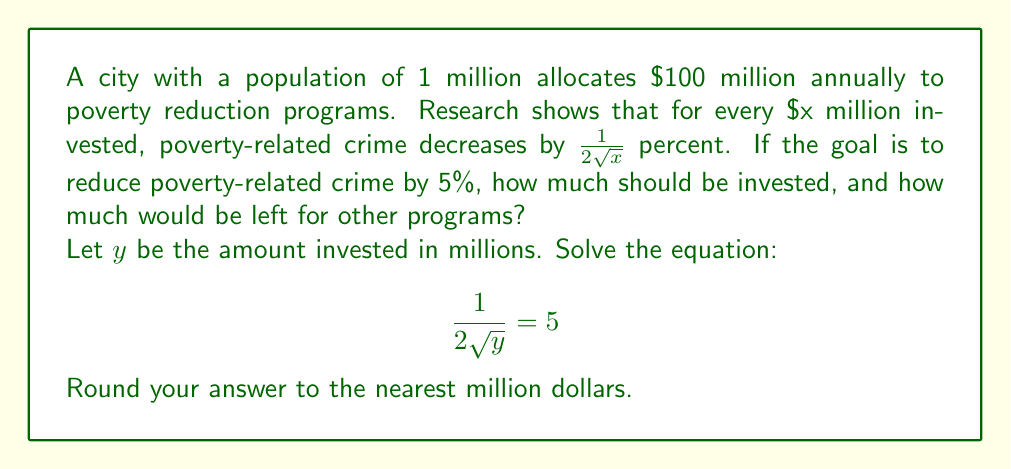Help me with this question. To solve this problem, we'll follow these steps:

1) Start with the equation:
   $$\frac{1}{2\sqrt{y}} = 5$$

2) Multiply both sides by $2\sqrt{y}$:
   $$1 = 10\sqrt{y}$$

3) Square both sides:
   $$1 = 100y$$

4) Divide both sides by 100:
   $$y = \frac{1}{100} = 0.01$$

5) Since $y$ is in millions of dollars, we multiply by 1,000,000:
   $$0.01 \times 1,000,000 = 10,000$$

6) Round to the nearest million:
   $10 million

7) Calculate the amount left for other programs:
   $100 million - $10 million = $90 million

Therefore, $10 million should be invested in poverty reduction programs, and $90 million would be left for other programs.
Answer: $10 million invested, $90 million left 